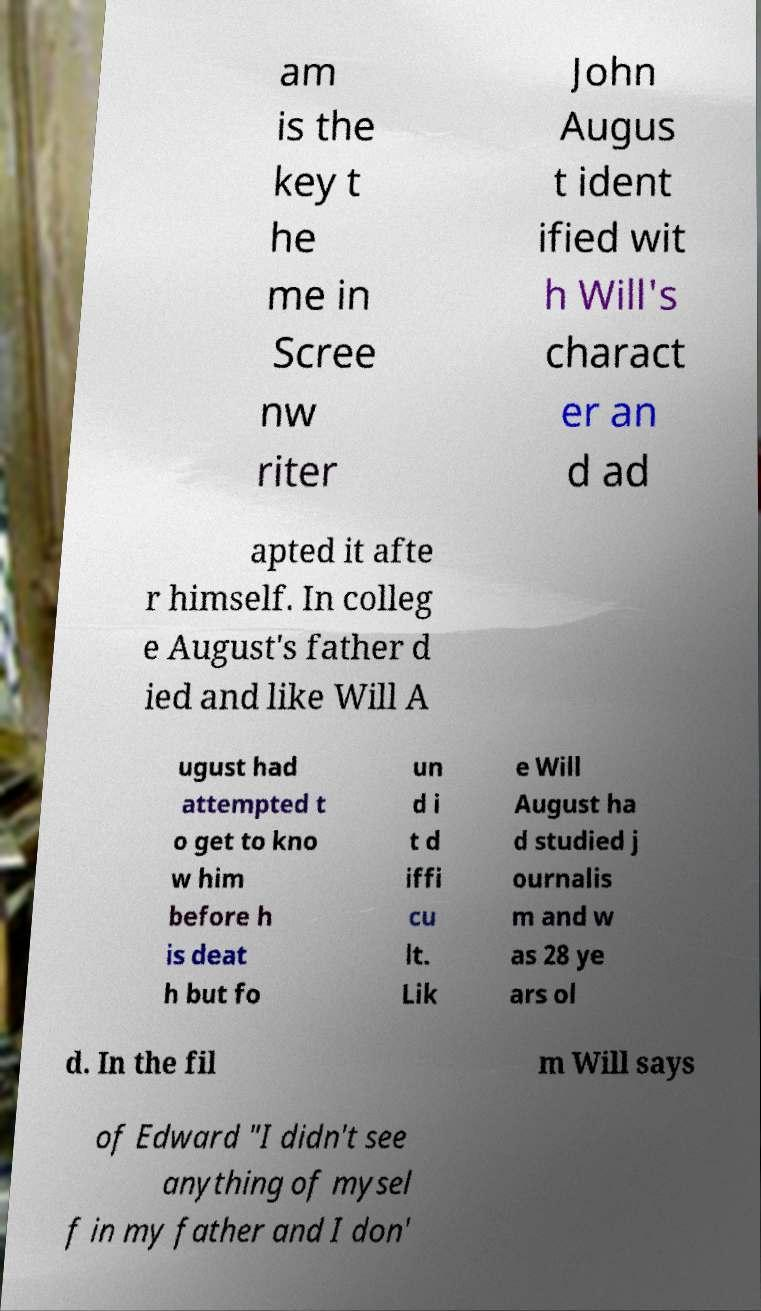For documentation purposes, I need the text within this image transcribed. Could you provide that? am is the key t he me in Scree nw riter John Augus t ident ified wit h Will's charact er an d ad apted it afte r himself. In colleg e August's father d ied and like Will A ugust had attempted t o get to kno w him before h is deat h but fo un d i t d iffi cu lt. Lik e Will August ha d studied j ournalis m and w as 28 ye ars ol d. In the fil m Will says of Edward "I didn't see anything of mysel f in my father and I don' 